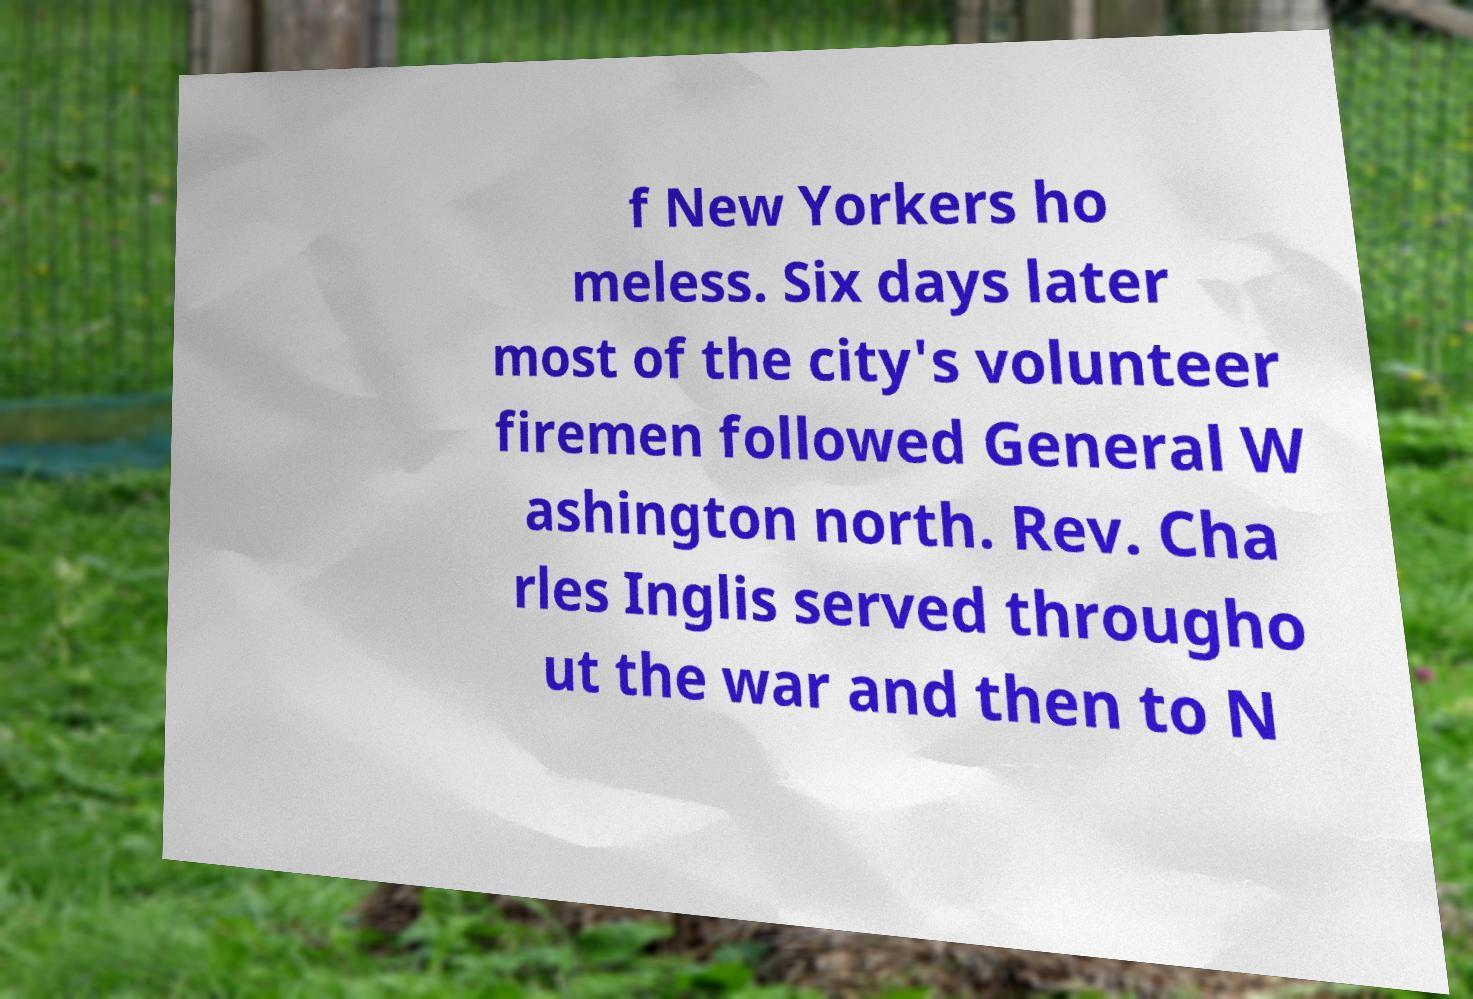Can you accurately transcribe the text from the provided image for me? f New Yorkers ho meless. Six days later most of the city's volunteer firemen followed General W ashington north. Rev. Cha rles Inglis served througho ut the war and then to N 